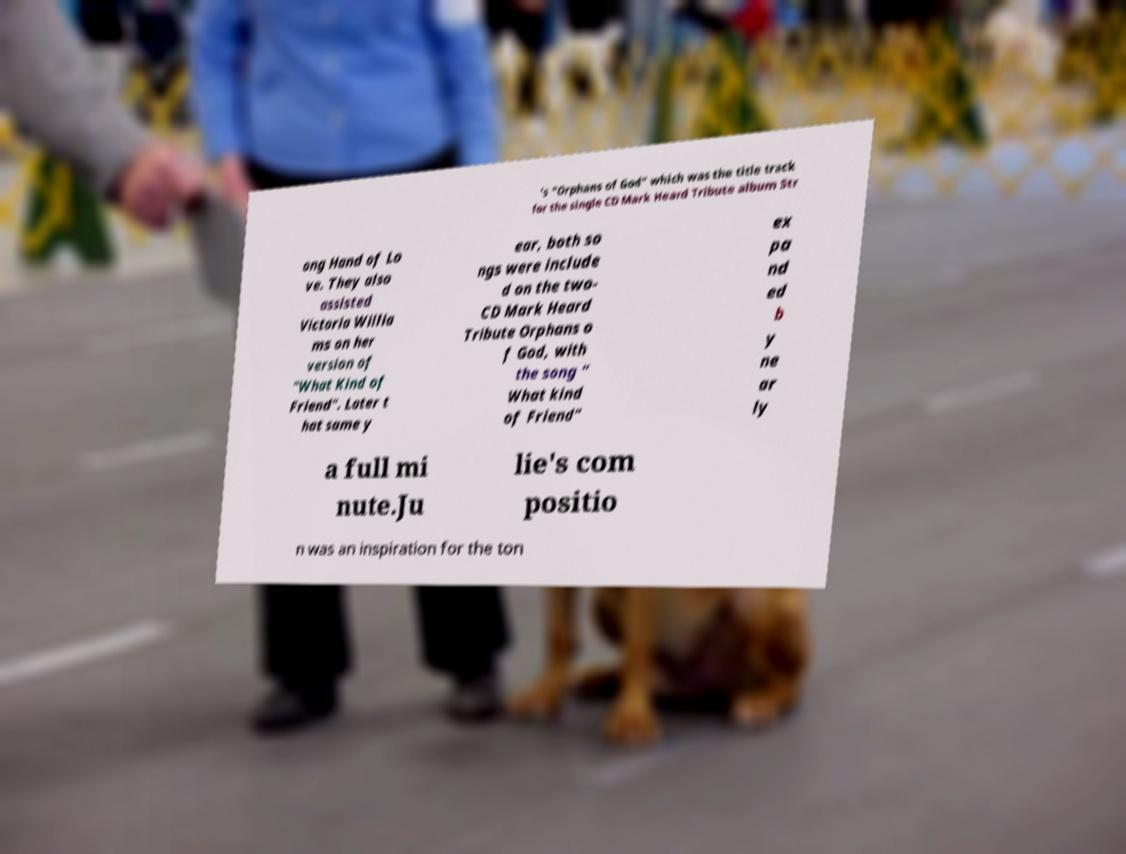Please read and relay the text visible in this image. What does it say? 's "Orphans of God" which was the title track for the single CD Mark Heard Tribute album Str ong Hand of Lo ve. They also assisted Victoria Willia ms on her version of "What Kind of Friend". Later t hat same y ear, both so ngs were include d on the two- CD Mark Heard Tribute Orphans o f God, with the song " What kind of Friend" ex pa nd ed b y ne ar ly a full mi nute.Ju lie's com positio n was an inspiration for the ton 